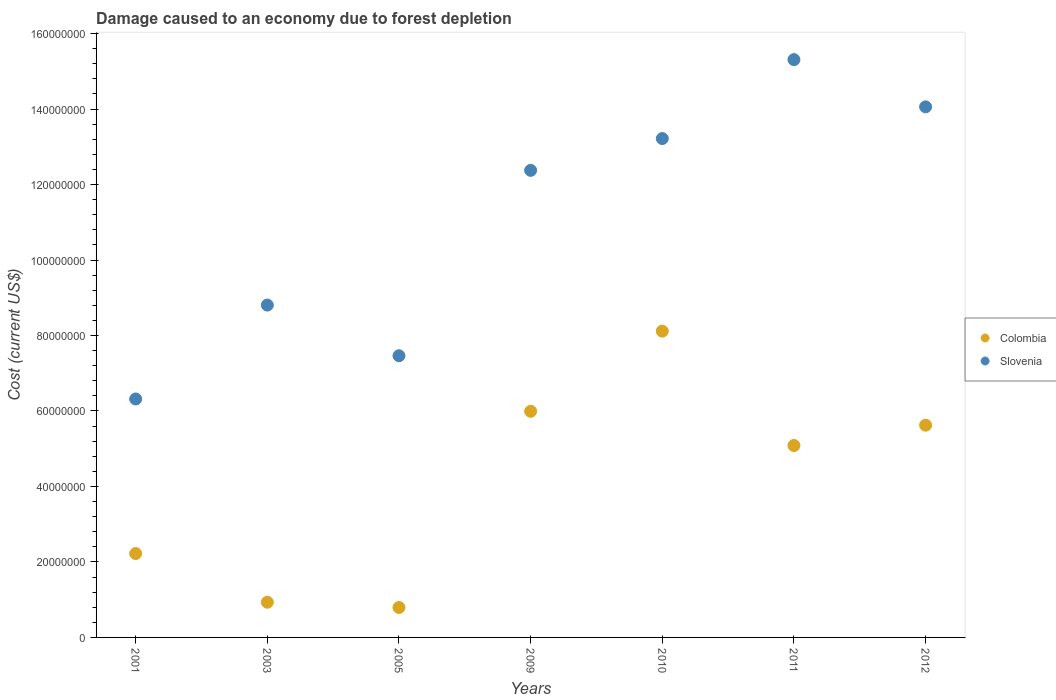What is the cost of damage caused due to forest depletion in Colombia in 2005?
Your answer should be very brief. 7.93e+06. Across all years, what is the maximum cost of damage caused due to forest depletion in Slovenia?
Keep it short and to the point. 1.53e+08. Across all years, what is the minimum cost of damage caused due to forest depletion in Colombia?
Give a very brief answer. 7.93e+06. What is the total cost of damage caused due to forest depletion in Colombia in the graph?
Offer a very short reply. 2.88e+08. What is the difference between the cost of damage caused due to forest depletion in Colombia in 2003 and that in 2009?
Make the answer very short. -5.06e+07. What is the difference between the cost of damage caused due to forest depletion in Slovenia in 2011 and the cost of damage caused due to forest depletion in Colombia in 2005?
Your answer should be very brief. 1.45e+08. What is the average cost of damage caused due to forest depletion in Colombia per year?
Ensure brevity in your answer.  4.11e+07. In the year 2010, what is the difference between the cost of damage caused due to forest depletion in Colombia and cost of damage caused due to forest depletion in Slovenia?
Your answer should be very brief. -5.10e+07. In how many years, is the cost of damage caused due to forest depletion in Colombia greater than 132000000 US$?
Offer a terse response. 0. What is the ratio of the cost of damage caused due to forest depletion in Slovenia in 2003 to that in 2005?
Keep it short and to the point. 1.18. Is the cost of damage caused due to forest depletion in Slovenia in 2005 less than that in 2009?
Your response must be concise. Yes. What is the difference between the highest and the second highest cost of damage caused due to forest depletion in Colombia?
Provide a succinct answer. 2.12e+07. What is the difference between the highest and the lowest cost of damage caused due to forest depletion in Slovenia?
Ensure brevity in your answer.  8.99e+07. In how many years, is the cost of damage caused due to forest depletion in Colombia greater than the average cost of damage caused due to forest depletion in Colombia taken over all years?
Make the answer very short. 4. Is the sum of the cost of damage caused due to forest depletion in Slovenia in 2001 and 2011 greater than the maximum cost of damage caused due to forest depletion in Colombia across all years?
Ensure brevity in your answer.  Yes. Does the cost of damage caused due to forest depletion in Slovenia monotonically increase over the years?
Make the answer very short. No. Is the cost of damage caused due to forest depletion in Slovenia strictly less than the cost of damage caused due to forest depletion in Colombia over the years?
Provide a succinct answer. No. How many dotlines are there?
Your answer should be compact. 2. How many years are there in the graph?
Offer a terse response. 7. Are the values on the major ticks of Y-axis written in scientific E-notation?
Give a very brief answer. No. Does the graph contain any zero values?
Offer a terse response. No. How many legend labels are there?
Your response must be concise. 2. What is the title of the graph?
Your answer should be very brief. Damage caused to an economy due to forest depletion. Does "Syrian Arab Republic" appear as one of the legend labels in the graph?
Your response must be concise. No. What is the label or title of the X-axis?
Ensure brevity in your answer.  Years. What is the label or title of the Y-axis?
Provide a short and direct response. Cost (current US$). What is the Cost (current US$) of Colombia in 2001?
Offer a terse response. 2.22e+07. What is the Cost (current US$) of Slovenia in 2001?
Provide a succinct answer. 6.32e+07. What is the Cost (current US$) of Colombia in 2003?
Offer a terse response. 9.33e+06. What is the Cost (current US$) of Slovenia in 2003?
Offer a terse response. 8.81e+07. What is the Cost (current US$) in Colombia in 2005?
Give a very brief answer. 7.93e+06. What is the Cost (current US$) of Slovenia in 2005?
Provide a succinct answer. 7.46e+07. What is the Cost (current US$) in Colombia in 2009?
Your answer should be very brief. 5.99e+07. What is the Cost (current US$) of Slovenia in 2009?
Your response must be concise. 1.24e+08. What is the Cost (current US$) of Colombia in 2010?
Provide a short and direct response. 8.12e+07. What is the Cost (current US$) in Slovenia in 2010?
Your response must be concise. 1.32e+08. What is the Cost (current US$) in Colombia in 2011?
Make the answer very short. 5.09e+07. What is the Cost (current US$) of Slovenia in 2011?
Offer a terse response. 1.53e+08. What is the Cost (current US$) of Colombia in 2012?
Keep it short and to the point. 5.62e+07. What is the Cost (current US$) in Slovenia in 2012?
Your answer should be compact. 1.41e+08. Across all years, what is the maximum Cost (current US$) in Colombia?
Your answer should be compact. 8.12e+07. Across all years, what is the maximum Cost (current US$) in Slovenia?
Make the answer very short. 1.53e+08. Across all years, what is the minimum Cost (current US$) of Colombia?
Ensure brevity in your answer.  7.93e+06. Across all years, what is the minimum Cost (current US$) in Slovenia?
Provide a short and direct response. 6.32e+07. What is the total Cost (current US$) in Colombia in the graph?
Give a very brief answer. 2.88e+08. What is the total Cost (current US$) in Slovenia in the graph?
Your response must be concise. 7.76e+08. What is the difference between the Cost (current US$) of Colombia in 2001 and that in 2003?
Provide a short and direct response. 1.29e+07. What is the difference between the Cost (current US$) in Slovenia in 2001 and that in 2003?
Ensure brevity in your answer.  -2.49e+07. What is the difference between the Cost (current US$) in Colombia in 2001 and that in 2005?
Make the answer very short. 1.43e+07. What is the difference between the Cost (current US$) in Slovenia in 2001 and that in 2005?
Provide a short and direct response. -1.15e+07. What is the difference between the Cost (current US$) of Colombia in 2001 and that in 2009?
Ensure brevity in your answer.  -3.77e+07. What is the difference between the Cost (current US$) in Slovenia in 2001 and that in 2009?
Offer a very short reply. -6.06e+07. What is the difference between the Cost (current US$) of Colombia in 2001 and that in 2010?
Give a very brief answer. -5.89e+07. What is the difference between the Cost (current US$) in Slovenia in 2001 and that in 2010?
Ensure brevity in your answer.  -6.90e+07. What is the difference between the Cost (current US$) in Colombia in 2001 and that in 2011?
Give a very brief answer. -2.86e+07. What is the difference between the Cost (current US$) in Slovenia in 2001 and that in 2011?
Make the answer very short. -8.99e+07. What is the difference between the Cost (current US$) of Colombia in 2001 and that in 2012?
Offer a very short reply. -3.40e+07. What is the difference between the Cost (current US$) in Slovenia in 2001 and that in 2012?
Give a very brief answer. -7.74e+07. What is the difference between the Cost (current US$) in Colombia in 2003 and that in 2005?
Offer a very short reply. 1.39e+06. What is the difference between the Cost (current US$) of Slovenia in 2003 and that in 2005?
Keep it short and to the point. 1.34e+07. What is the difference between the Cost (current US$) of Colombia in 2003 and that in 2009?
Provide a succinct answer. -5.06e+07. What is the difference between the Cost (current US$) of Slovenia in 2003 and that in 2009?
Provide a short and direct response. -3.57e+07. What is the difference between the Cost (current US$) of Colombia in 2003 and that in 2010?
Your answer should be compact. -7.18e+07. What is the difference between the Cost (current US$) of Slovenia in 2003 and that in 2010?
Offer a terse response. -4.41e+07. What is the difference between the Cost (current US$) of Colombia in 2003 and that in 2011?
Provide a succinct answer. -4.15e+07. What is the difference between the Cost (current US$) of Slovenia in 2003 and that in 2011?
Provide a short and direct response. -6.50e+07. What is the difference between the Cost (current US$) in Colombia in 2003 and that in 2012?
Offer a terse response. -4.69e+07. What is the difference between the Cost (current US$) in Slovenia in 2003 and that in 2012?
Your answer should be very brief. -5.25e+07. What is the difference between the Cost (current US$) of Colombia in 2005 and that in 2009?
Ensure brevity in your answer.  -5.20e+07. What is the difference between the Cost (current US$) in Slovenia in 2005 and that in 2009?
Give a very brief answer. -4.91e+07. What is the difference between the Cost (current US$) of Colombia in 2005 and that in 2010?
Ensure brevity in your answer.  -7.32e+07. What is the difference between the Cost (current US$) of Slovenia in 2005 and that in 2010?
Keep it short and to the point. -5.75e+07. What is the difference between the Cost (current US$) in Colombia in 2005 and that in 2011?
Keep it short and to the point. -4.29e+07. What is the difference between the Cost (current US$) of Slovenia in 2005 and that in 2011?
Offer a very short reply. -7.85e+07. What is the difference between the Cost (current US$) in Colombia in 2005 and that in 2012?
Your answer should be compact. -4.83e+07. What is the difference between the Cost (current US$) in Slovenia in 2005 and that in 2012?
Provide a short and direct response. -6.59e+07. What is the difference between the Cost (current US$) in Colombia in 2009 and that in 2010?
Give a very brief answer. -2.12e+07. What is the difference between the Cost (current US$) of Slovenia in 2009 and that in 2010?
Keep it short and to the point. -8.43e+06. What is the difference between the Cost (current US$) in Colombia in 2009 and that in 2011?
Provide a short and direct response. 9.06e+06. What is the difference between the Cost (current US$) of Slovenia in 2009 and that in 2011?
Your answer should be compact. -2.93e+07. What is the difference between the Cost (current US$) of Colombia in 2009 and that in 2012?
Give a very brief answer. 3.69e+06. What is the difference between the Cost (current US$) in Slovenia in 2009 and that in 2012?
Offer a terse response. -1.68e+07. What is the difference between the Cost (current US$) in Colombia in 2010 and that in 2011?
Ensure brevity in your answer.  3.03e+07. What is the difference between the Cost (current US$) in Slovenia in 2010 and that in 2011?
Ensure brevity in your answer.  -2.09e+07. What is the difference between the Cost (current US$) of Colombia in 2010 and that in 2012?
Provide a short and direct response. 2.49e+07. What is the difference between the Cost (current US$) of Slovenia in 2010 and that in 2012?
Provide a succinct answer. -8.40e+06. What is the difference between the Cost (current US$) in Colombia in 2011 and that in 2012?
Offer a very short reply. -5.38e+06. What is the difference between the Cost (current US$) of Slovenia in 2011 and that in 2012?
Make the answer very short. 1.25e+07. What is the difference between the Cost (current US$) of Colombia in 2001 and the Cost (current US$) of Slovenia in 2003?
Make the answer very short. -6.58e+07. What is the difference between the Cost (current US$) in Colombia in 2001 and the Cost (current US$) in Slovenia in 2005?
Your answer should be very brief. -5.24e+07. What is the difference between the Cost (current US$) in Colombia in 2001 and the Cost (current US$) in Slovenia in 2009?
Your answer should be very brief. -1.02e+08. What is the difference between the Cost (current US$) in Colombia in 2001 and the Cost (current US$) in Slovenia in 2010?
Give a very brief answer. -1.10e+08. What is the difference between the Cost (current US$) in Colombia in 2001 and the Cost (current US$) in Slovenia in 2011?
Make the answer very short. -1.31e+08. What is the difference between the Cost (current US$) of Colombia in 2001 and the Cost (current US$) of Slovenia in 2012?
Offer a terse response. -1.18e+08. What is the difference between the Cost (current US$) of Colombia in 2003 and the Cost (current US$) of Slovenia in 2005?
Offer a very short reply. -6.53e+07. What is the difference between the Cost (current US$) of Colombia in 2003 and the Cost (current US$) of Slovenia in 2009?
Give a very brief answer. -1.14e+08. What is the difference between the Cost (current US$) of Colombia in 2003 and the Cost (current US$) of Slovenia in 2010?
Offer a very short reply. -1.23e+08. What is the difference between the Cost (current US$) in Colombia in 2003 and the Cost (current US$) in Slovenia in 2011?
Offer a terse response. -1.44e+08. What is the difference between the Cost (current US$) of Colombia in 2003 and the Cost (current US$) of Slovenia in 2012?
Your response must be concise. -1.31e+08. What is the difference between the Cost (current US$) in Colombia in 2005 and the Cost (current US$) in Slovenia in 2009?
Make the answer very short. -1.16e+08. What is the difference between the Cost (current US$) in Colombia in 2005 and the Cost (current US$) in Slovenia in 2010?
Your answer should be compact. -1.24e+08. What is the difference between the Cost (current US$) in Colombia in 2005 and the Cost (current US$) in Slovenia in 2011?
Provide a short and direct response. -1.45e+08. What is the difference between the Cost (current US$) in Colombia in 2005 and the Cost (current US$) in Slovenia in 2012?
Offer a terse response. -1.33e+08. What is the difference between the Cost (current US$) of Colombia in 2009 and the Cost (current US$) of Slovenia in 2010?
Provide a short and direct response. -7.23e+07. What is the difference between the Cost (current US$) of Colombia in 2009 and the Cost (current US$) of Slovenia in 2011?
Your answer should be compact. -9.32e+07. What is the difference between the Cost (current US$) in Colombia in 2009 and the Cost (current US$) in Slovenia in 2012?
Your response must be concise. -8.07e+07. What is the difference between the Cost (current US$) in Colombia in 2010 and the Cost (current US$) in Slovenia in 2011?
Your response must be concise. -7.19e+07. What is the difference between the Cost (current US$) of Colombia in 2010 and the Cost (current US$) of Slovenia in 2012?
Your response must be concise. -5.94e+07. What is the difference between the Cost (current US$) in Colombia in 2011 and the Cost (current US$) in Slovenia in 2012?
Make the answer very short. -8.97e+07. What is the average Cost (current US$) in Colombia per year?
Provide a short and direct response. 4.11e+07. What is the average Cost (current US$) in Slovenia per year?
Your answer should be compact. 1.11e+08. In the year 2001, what is the difference between the Cost (current US$) of Colombia and Cost (current US$) of Slovenia?
Offer a terse response. -4.10e+07. In the year 2003, what is the difference between the Cost (current US$) in Colombia and Cost (current US$) in Slovenia?
Your response must be concise. -7.87e+07. In the year 2005, what is the difference between the Cost (current US$) in Colombia and Cost (current US$) in Slovenia?
Keep it short and to the point. -6.67e+07. In the year 2009, what is the difference between the Cost (current US$) in Colombia and Cost (current US$) in Slovenia?
Your answer should be very brief. -6.38e+07. In the year 2010, what is the difference between the Cost (current US$) of Colombia and Cost (current US$) of Slovenia?
Provide a short and direct response. -5.10e+07. In the year 2011, what is the difference between the Cost (current US$) in Colombia and Cost (current US$) in Slovenia?
Ensure brevity in your answer.  -1.02e+08. In the year 2012, what is the difference between the Cost (current US$) of Colombia and Cost (current US$) of Slovenia?
Provide a succinct answer. -8.43e+07. What is the ratio of the Cost (current US$) of Colombia in 2001 to that in 2003?
Make the answer very short. 2.38. What is the ratio of the Cost (current US$) in Slovenia in 2001 to that in 2003?
Provide a short and direct response. 0.72. What is the ratio of the Cost (current US$) of Colombia in 2001 to that in 2005?
Offer a terse response. 2.8. What is the ratio of the Cost (current US$) in Slovenia in 2001 to that in 2005?
Keep it short and to the point. 0.85. What is the ratio of the Cost (current US$) in Colombia in 2001 to that in 2009?
Ensure brevity in your answer.  0.37. What is the ratio of the Cost (current US$) in Slovenia in 2001 to that in 2009?
Your answer should be compact. 0.51. What is the ratio of the Cost (current US$) of Colombia in 2001 to that in 2010?
Your answer should be compact. 0.27. What is the ratio of the Cost (current US$) of Slovenia in 2001 to that in 2010?
Your answer should be very brief. 0.48. What is the ratio of the Cost (current US$) in Colombia in 2001 to that in 2011?
Offer a very short reply. 0.44. What is the ratio of the Cost (current US$) in Slovenia in 2001 to that in 2011?
Ensure brevity in your answer.  0.41. What is the ratio of the Cost (current US$) in Colombia in 2001 to that in 2012?
Provide a succinct answer. 0.4. What is the ratio of the Cost (current US$) of Slovenia in 2001 to that in 2012?
Make the answer very short. 0.45. What is the ratio of the Cost (current US$) of Colombia in 2003 to that in 2005?
Make the answer very short. 1.18. What is the ratio of the Cost (current US$) in Slovenia in 2003 to that in 2005?
Provide a short and direct response. 1.18. What is the ratio of the Cost (current US$) in Colombia in 2003 to that in 2009?
Provide a succinct answer. 0.16. What is the ratio of the Cost (current US$) of Slovenia in 2003 to that in 2009?
Ensure brevity in your answer.  0.71. What is the ratio of the Cost (current US$) in Colombia in 2003 to that in 2010?
Provide a succinct answer. 0.11. What is the ratio of the Cost (current US$) of Slovenia in 2003 to that in 2010?
Ensure brevity in your answer.  0.67. What is the ratio of the Cost (current US$) of Colombia in 2003 to that in 2011?
Your response must be concise. 0.18. What is the ratio of the Cost (current US$) in Slovenia in 2003 to that in 2011?
Give a very brief answer. 0.58. What is the ratio of the Cost (current US$) of Colombia in 2003 to that in 2012?
Provide a short and direct response. 0.17. What is the ratio of the Cost (current US$) of Slovenia in 2003 to that in 2012?
Your answer should be very brief. 0.63. What is the ratio of the Cost (current US$) of Colombia in 2005 to that in 2009?
Offer a terse response. 0.13. What is the ratio of the Cost (current US$) of Slovenia in 2005 to that in 2009?
Offer a terse response. 0.6. What is the ratio of the Cost (current US$) of Colombia in 2005 to that in 2010?
Provide a short and direct response. 0.1. What is the ratio of the Cost (current US$) in Slovenia in 2005 to that in 2010?
Provide a short and direct response. 0.56. What is the ratio of the Cost (current US$) of Colombia in 2005 to that in 2011?
Give a very brief answer. 0.16. What is the ratio of the Cost (current US$) of Slovenia in 2005 to that in 2011?
Ensure brevity in your answer.  0.49. What is the ratio of the Cost (current US$) in Colombia in 2005 to that in 2012?
Make the answer very short. 0.14. What is the ratio of the Cost (current US$) of Slovenia in 2005 to that in 2012?
Keep it short and to the point. 0.53. What is the ratio of the Cost (current US$) in Colombia in 2009 to that in 2010?
Offer a very short reply. 0.74. What is the ratio of the Cost (current US$) of Slovenia in 2009 to that in 2010?
Give a very brief answer. 0.94. What is the ratio of the Cost (current US$) of Colombia in 2009 to that in 2011?
Offer a very short reply. 1.18. What is the ratio of the Cost (current US$) in Slovenia in 2009 to that in 2011?
Provide a short and direct response. 0.81. What is the ratio of the Cost (current US$) of Colombia in 2009 to that in 2012?
Make the answer very short. 1.07. What is the ratio of the Cost (current US$) in Slovenia in 2009 to that in 2012?
Your answer should be compact. 0.88. What is the ratio of the Cost (current US$) of Colombia in 2010 to that in 2011?
Your answer should be very brief. 1.6. What is the ratio of the Cost (current US$) in Slovenia in 2010 to that in 2011?
Provide a short and direct response. 0.86. What is the ratio of the Cost (current US$) of Colombia in 2010 to that in 2012?
Ensure brevity in your answer.  1.44. What is the ratio of the Cost (current US$) of Slovenia in 2010 to that in 2012?
Your answer should be very brief. 0.94. What is the ratio of the Cost (current US$) of Colombia in 2011 to that in 2012?
Keep it short and to the point. 0.9. What is the ratio of the Cost (current US$) of Slovenia in 2011 to that in 2012?
Your response must be concise. 1.09. What is the difference between the highest and the second highest Cost (current US$) in Colombia?
Your response must be concise. 2.12e+07. What is the difference between the highest and the second highest Cost (current US$) of Slovenia?
Your answer should be very brief. 1.25e+07. What is the difference between the highest and the lowest Cost (current US$) of Colombia?
Provide a succinct answer. 7.32e+07. What is the difference between the highest and the lowest Cost (current US$) of Slovenia?
Provide a succinct answer. 8.99e+07. 